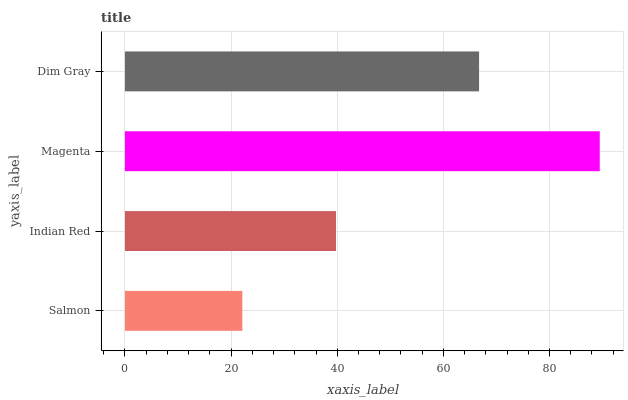Is Salmon the minimum?
Answer yes or no. Yes. Is Magenta the maximum?
Answer yes or no. Yes. Is Indian Red the minimum?
Answer yes or no. No. Is Indian Red the maximum?
Answer yes or no. No. Is Indian Red greater than Salmon?
Answer yes or no. Yes. Is Salmon less than Indian Red?
Answer yes or no. Yes. Is Salmon greater than Indian Red?
Answer yes or no. No. Is Indian Red less than Salmon?
Answer yes or no. No. Is Dim Gray the high median?
Answer yes or no. Yes. Is Indian Red the low median?
Answer yes or no. Yes. Is Salmon the high median?
Answer yes or no. No. Is Salmon the low median?
Answer yes or no. No. 